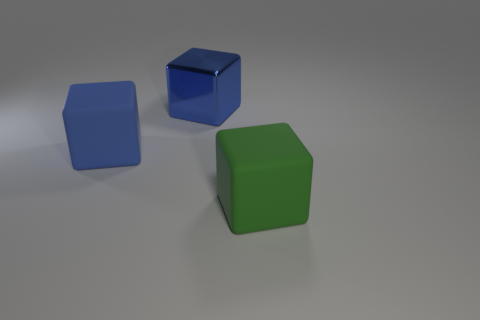What is the texture of the objects and how does it add to the overall visual effect? The objects have a matte texture which diffuses light and softens reflections. This texture eliminates any harsh glares and contributes to the image's serene and simplistic aesthetic. It emphasizes the purity of the geometric shapes and the tranquil atmosphere of the composition. 